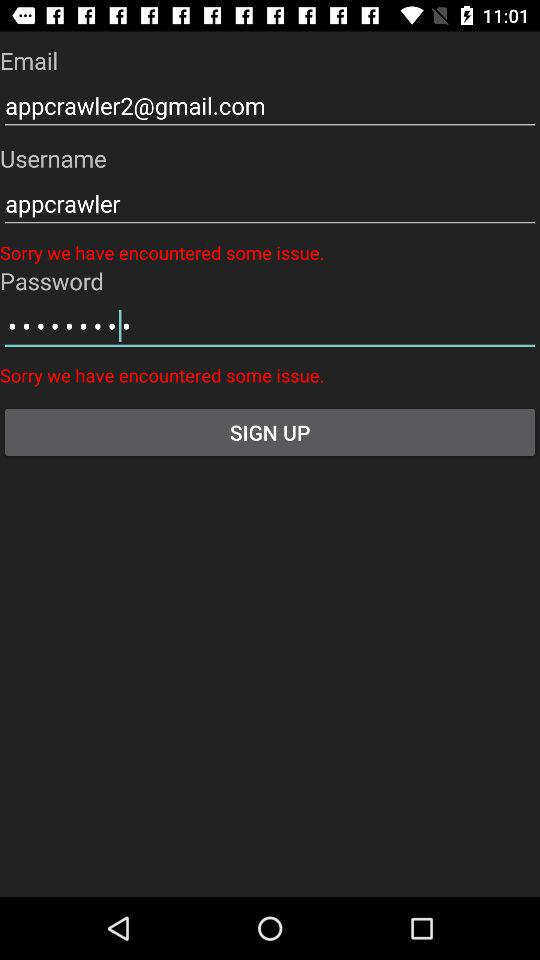What is the username? The username is "appcrawler". 